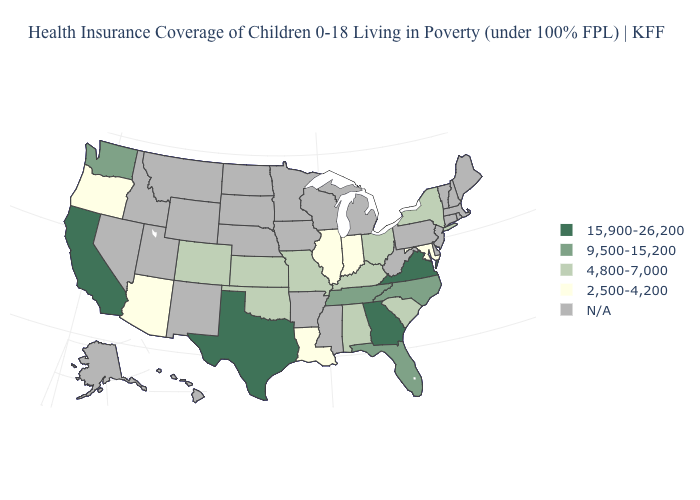What is the lowest value in the USA?
Concise answer only. 2,500-4,200. Which states have the lowest value in the MidWest?
Answer briefly. Illinois, Indiana. What is the value of South Carolina?
Be succinct. 4,800-7,000. Name the states that have a value in the range 15,900-26,200?
Short answer required. California, Georgia, Texas, Virginia. What is the value of Texas?
Short answer required. 15,900-26,200. What is the lowest value in the USA?
Give a very brief answer. 2,500-4,200. What is the lowest value in states that border Kansas?
Write a very short answer. 4,800-7,000. What is the value of Michigan?
Short answer required. N/A. What is the value of Georgia?
Short answer required. 15,900-26,200. Name the states that have a value in the range 4,800-7,000?
Answer briefly. Alabama, Colorado, Kansas, Kentucky, Missouri, New York, Ohio, Oklahoma, South Carolina. Among the states that border Colorado , which have the lowest value?
Be succinct. Arizona. Name the states that have a value in the range 15,900-26,200?
Write a very short answer. California, Georgia, Texas, Virginia. What is the lowest value in the South?
Concise answer only. 2,500-4,200. Does the first symbol in the legend represent the smallest category?
Give a very brief answer. No. What is the highest value in states that border Massachusetts?
Answer briefly. 4,800-7,000. 